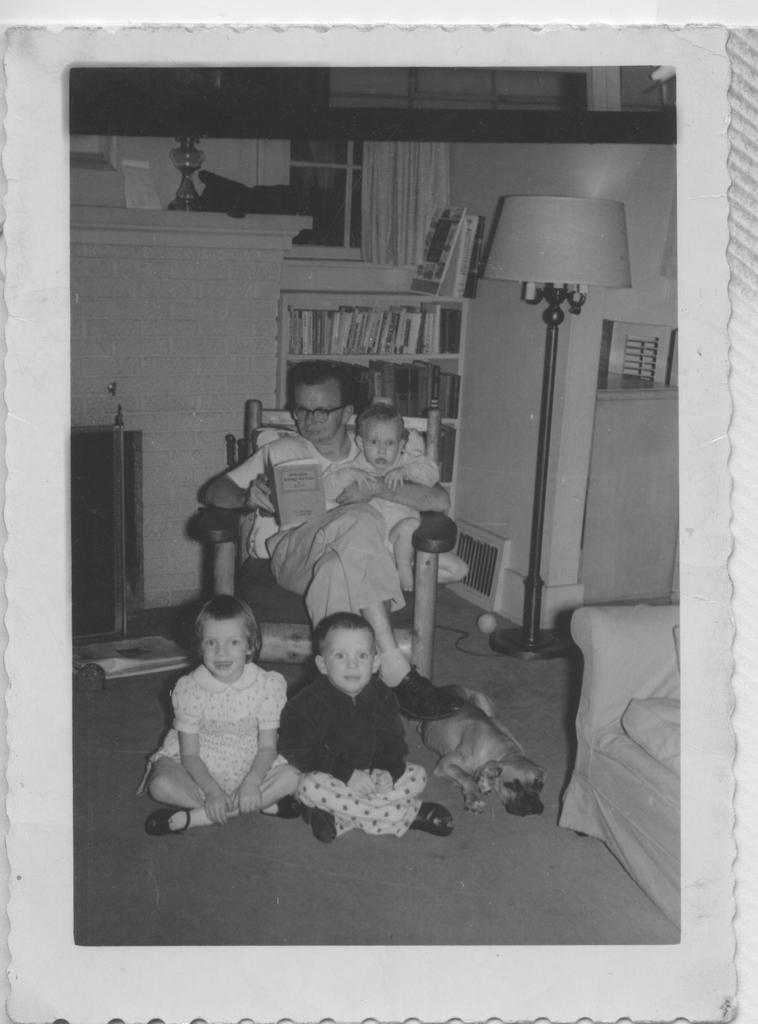Please provide a concise description of this image. In this black and white image, we can see photo of a picture. There is a person in the middle of the image holding a baby and sitting on the chair in front of the rack. There is a lamp on the right side of the image. There is a fireplace on the left side of the image. There are kids sitting on the ground. There is a dog beside the sofa. 